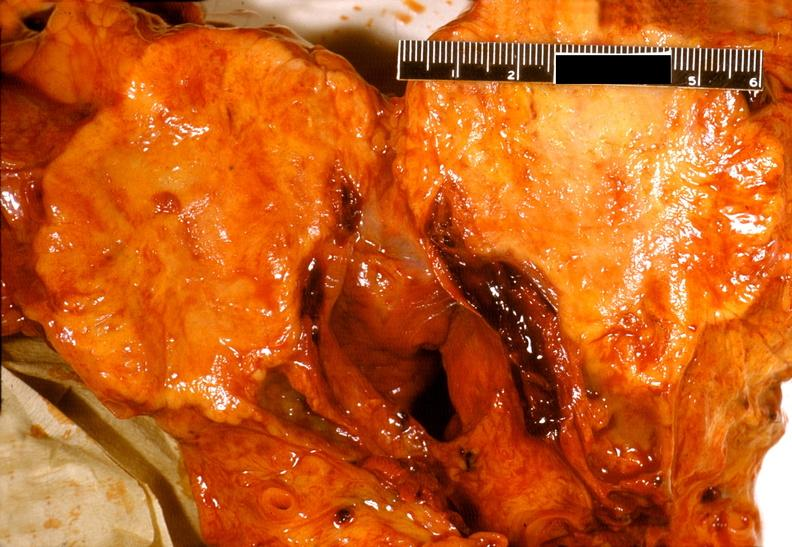what does this image show?
Answer the question using a single word or phrase. Adenocarcinoma 